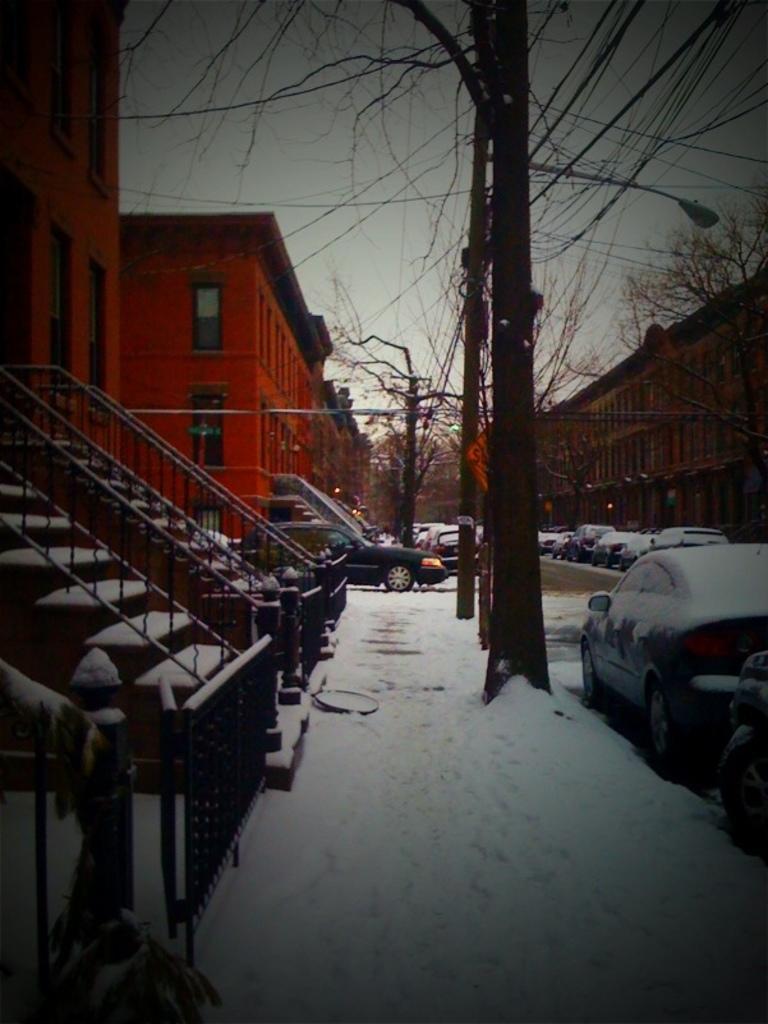Can you describe this image briefly? Here we can see snow on the footpath and road. On the left we can see steps,fences,buildings and windows. In the background there are vehicles on the road,buildings,bare trees and sky. 